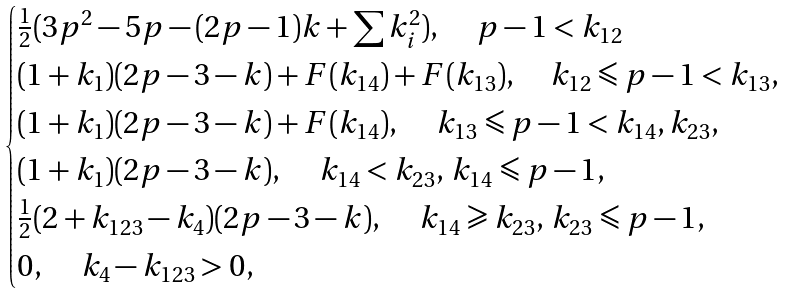Convert formula to latex. <formula><loc_0><loc_0><loc_500><loc_500>\begin{cases} \frac { 1 } { 2 } ( 3 p ^ { 2 } - 5 p - ( 2 p - 1 ) k + \sum k _ { i } ^ { 2 } ) , \quad \, p - 1 < k _ { 1 2 } \\ ( 1 + k _ { 1 } ) ( 2 p - 3 - k ) + F ( k _ { 1 4 } ) + F ( k _ { 1 3 } ) , \quad k _ { 1 2 } \leqslant p - 1 < k _ { 1 3 } , \\ ( 1 + k _ { 1 } ) ( 2 p - 3 - k ) + F ( k _ { 1 4 } ) , \quad \, k _ { 1 3 } \leqslant p - 1 < k _ { 1 4 } , k _ { 2 3 } , \\ ( 1 + k _ { 1 } ) ( 2 p - 3 - k ) , \quad \, k _ { 1 4 } < k _ { 2 3 } , \, k _ { 1 4 } \leqslant p - 1 , \\ \frac { 1 } { 2 } ( 2 + k _ { 1 2 3 } - k _ { 4 } ) ( 2 p - 3 - k ) , \quad \, k _ { 1 4 } \geqslant k _ { 2 3 } , \, k _ { 2 3 } \leqslant p - 1 , \\ 0 , \quad \, k _ { 4 } - k _ { 1 2 3 } > 0 , \\ \end{cases}</formula> 